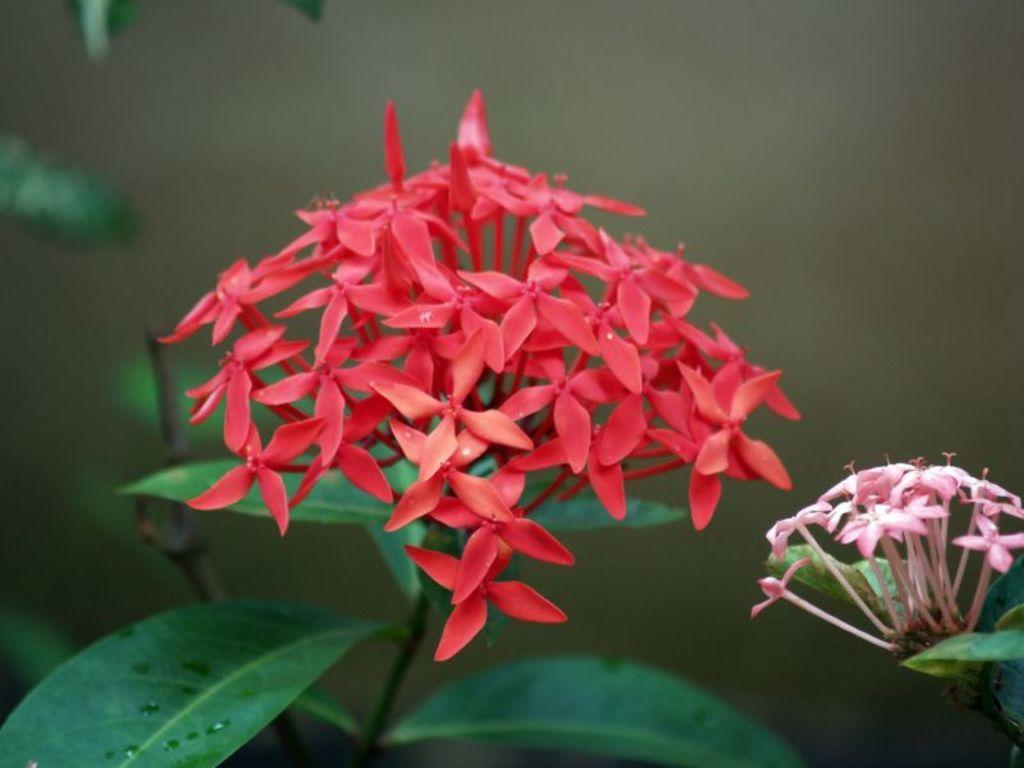Describe this image in one or two sentences. In this image we can see two different colors of flowers which are in pink and red and in the background of the image we can see some leaves. 